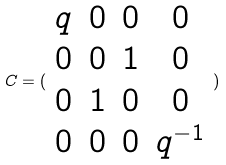Convert formula to latex. <formula><loc_0><loc_0><loc_500><loc_500>C = ( \begin{array} { c c c c } q & 0 & 0 & 0 \\ 0 & 0 & 1 & 0 \\ 0 & 1 & 0 & 0 \\ 0 & 0 & 0 & q ^ { - 1 } \end{array} )</formula> 